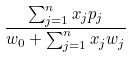<formula> <loc_0><loc_0><loc_500><loc_500>\frac { \sum _ { j = 1 } ^ { n } x _ { j } p _ { j } } { w _ { 0 } + \sum _ { j = 1 } ^ { n } x _ { j } w _ { j } }</formula> 